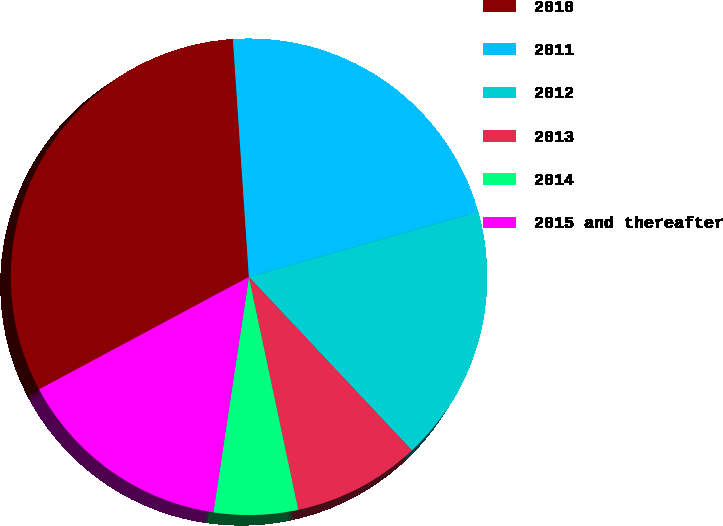Convert chart. <chart><loc_0><loc_0><loc_500><loc_500><pie_chart><fcel>2010<fcel>2011<fcel>2012<fcel>2013<fcel>2014<fcel>2015 and thereafter<nl><fcel>31.76%<fcel>21.67%<fcel>17.39%<fcel>8.68%<fcel>5.71%<fcel>14.79%<nl></chart> 